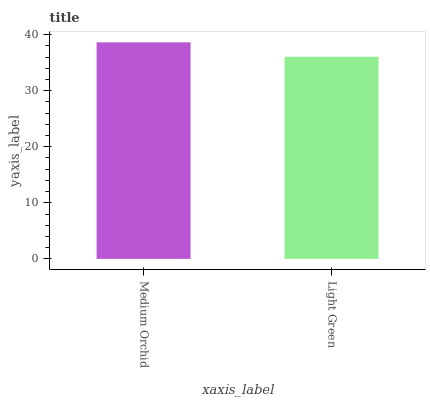Is Light Green the minimum?
Answer yes or no. Yes. Is Medium Orchid the maximum?
Answer yes or no. Yes. Is Light Green the maximum?
Answer yes or no. No. Is Medium Orchid greater than Light Green?
Answer yes or no. Yes. Is Light Green less than Medium Orchid?
Answer yes or no. Yes. Is Light Green greater than Medium Orchid?
Answer yes or no. No. Is Medium Orchid less than Light Green?
Answer yes or no. No. Is Medium Orchid the high median?
Answer yes or no. Yes. Is Light Green the low median?
Answer yes or no. Yes. Is Light Green the high median?
Answer yes or no. No. Is Medium Orchid the low median?
Answer yes or no. No. 